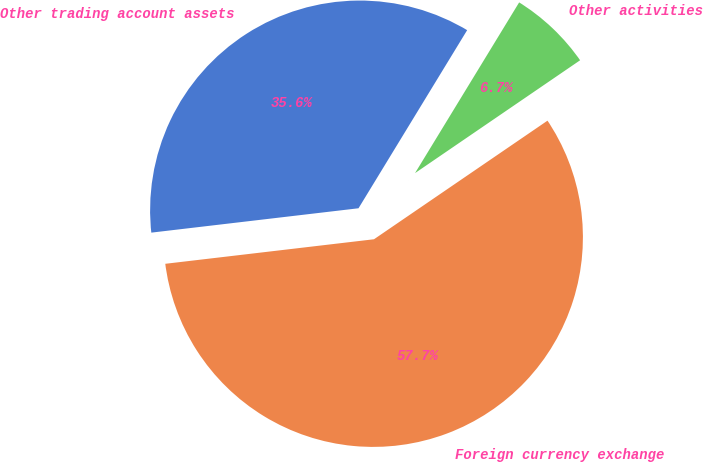Convert chart to OTSL. <chart><loc_0><loc_0><loc_500><loc_500><pie_chart><fcel>Other trading account assets<fcel>Foreign currency exchange<fcel>Other activities<nl><fcel>35.58%<fcel>57.68%<fcel>6.74%<nl></chart> 